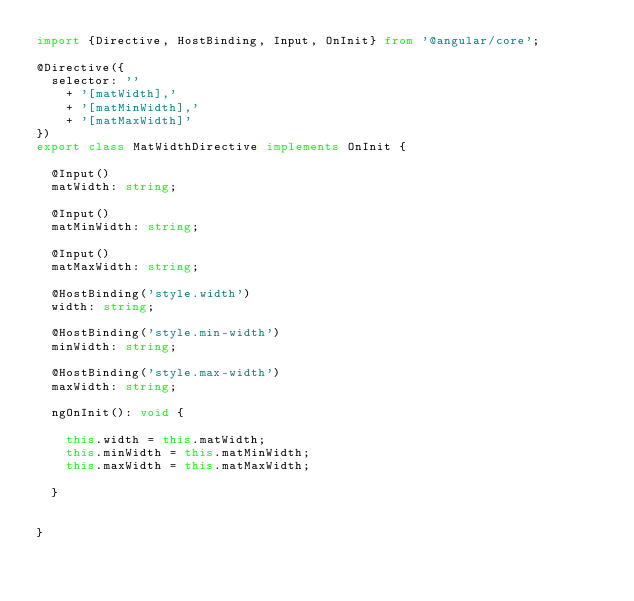<code> <loc_0><loc_0><loc_500><loc_500><_TypeScript_>import {Directive, HostBinding, Input, OnInit} from '@angular/core';

@Directive({
  selector: ''
    + '[matWidth],'
    + '[matMinWidth],'
    + '[matMaxWidth]'
})
export class MatWidthDirective implements OnInit {

  @Input()
  matWidth: string;

  @Input()
  matMinWidth: string;

  @Input()
  matMaxWidth: string;

  @HostBinding('style.width')
  width: string;

  @HostBinding('style.min-width')
  minWidth: string;

  @HostBinding('style.max-width')
  maxWidth: string;

  ngOnInit(): void {

    this.width = this.matWidth;
    this.minWidth = this.matMinWidth;
    this.maxWidth = this.matMaxWidth;

  }


}
</code> 